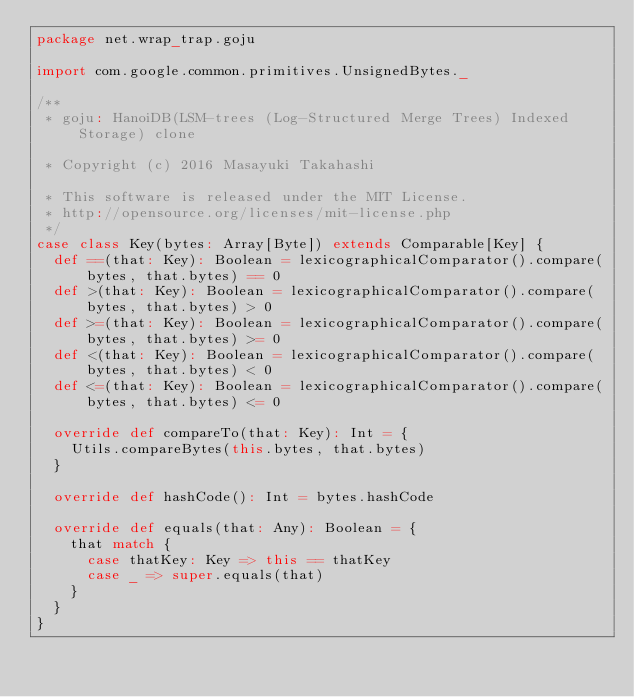<code> <loc_0><loc_0><loc_500><loc_500><_Scala_>package net.wrap_trap.goju

import com.google.common.primitives.UnsignedBytes._

/**
 * goju: HanoiDB(LSM-trees (Log-Structured Merge Trees) Indexed Storage) clone

 * Copyright (c) 2016 Masayuki Takahashi

 * This software is released under the MIT License.
 * http://opensource.org/licenses/mit-license.php
 */
case class Key(bytes: Array[Byte]) extends Comparable[Key] {
  def ==(that: Key): Boolean = lexicographicalComparator().compare(bytes, that.bytes) == 0
  def >(that: Key): Boolean = lexicographicalComparator().compare(bytes, that.bytes) > 0
  def >=(that: Key): Boolean = lexicographicalComparator().compare(bytes, that.bytes) >= 0
  def <(that: Key): Boolean = lexicographicalComparator().compare(bytes, that.bytes) < 0
  def <=(that: Key): Boolean = lexicographicalComparator().compare(bytes, that.bytes) <= 0

  override def compareTo(that: Key): Int = {
    Utils.compareBytes(this.bytes, that.bytes)
  }

  override def hashCode(): Int = bytes.hashCode

  override def equals(that: Any): Boolean = {
    that match {
      case thatKey: Key => this == thatKey
      case _ => super.equals(that)
    }
  }
}
</code> 